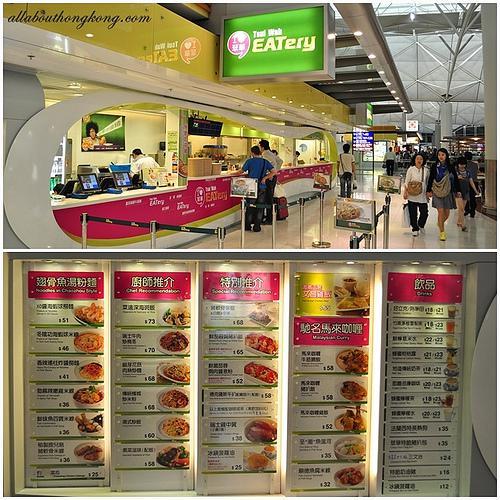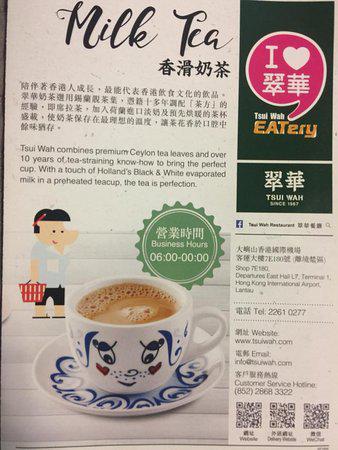The first image is the image on the left, the second image is the image on the right. Examine the images to the left and right. Is the description "One of the menus features over twenty pictures of the items." accurate? Answer yes or no. Yes. The first image is the image on the left, the second image is the image on the right. Analyze the images presented: Is the assertion "There are five lined menus in a row with pink headers." valid? Answer yes or no. Yes. 